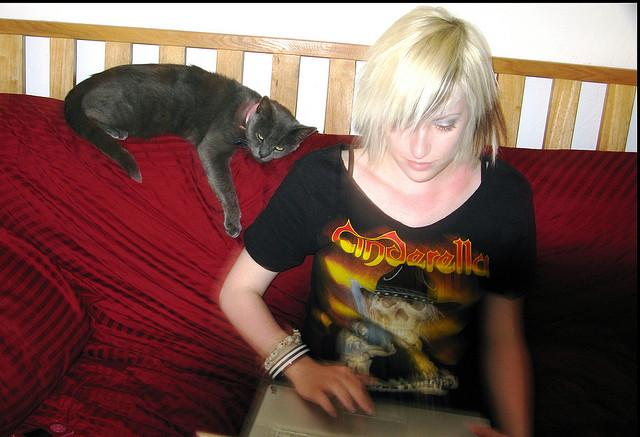What type of furniture is the girl sitting on? couch 